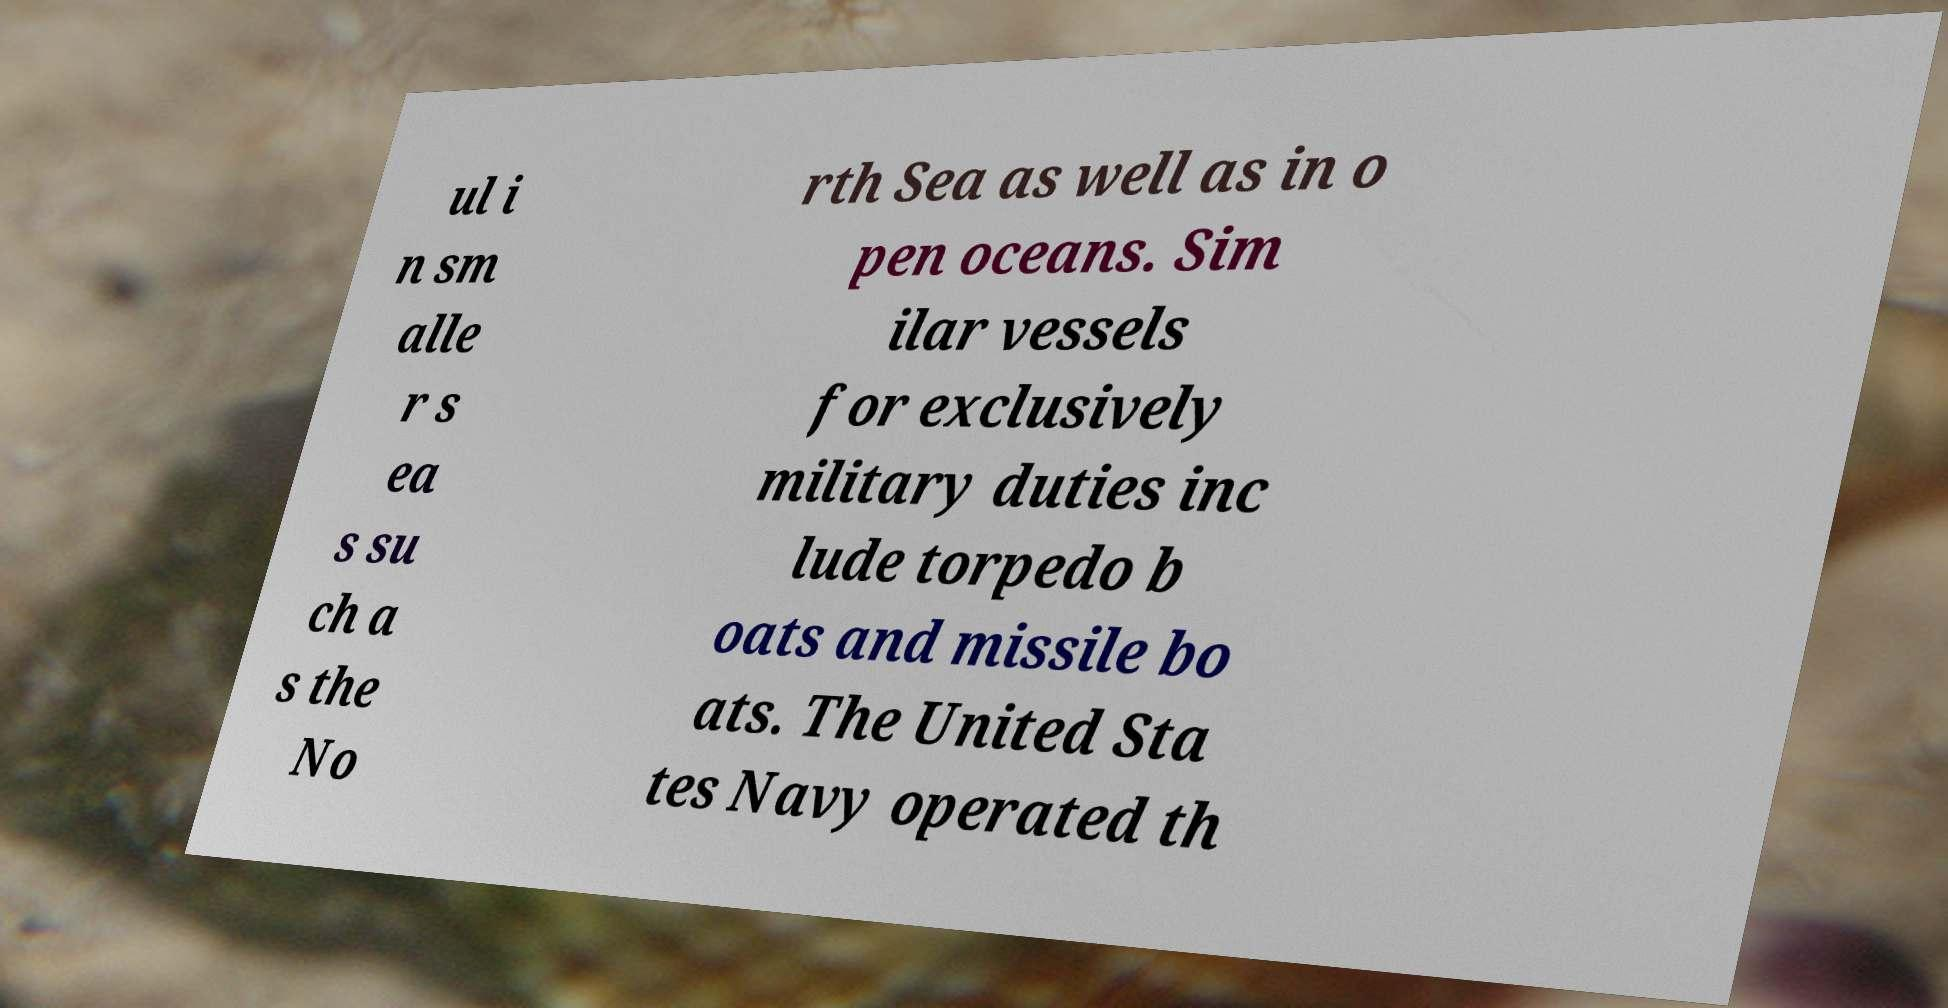What messages or text are displayed in this image? I need them in a readable, typed format. ul i n sm alle r s ea s su ch a s the No rth Sea as well as in o pen oceans. Sim ilar vessels for exclusively military duties inc lude torpedo b oats and missile bo ats. The United Sta tes Navy operated th 